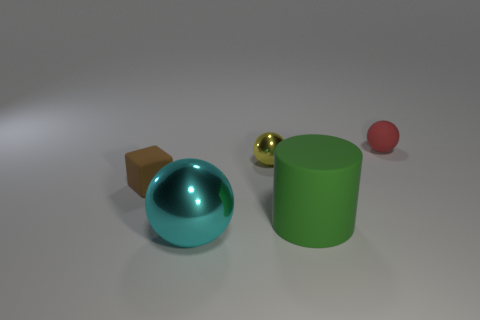Add 1 large cyan balls. How many objects exist? 6 Subtract all spheres. How many objects are left? 2 Subtract 0 green blocks. How many objects are left? 5 Subtract all large balls. Subtract all tiny yellow balls. How many objects are left? 3 Add 3 large rubber things. How many large rubber things are left? 4 Add 4 small red objects. How many small red objects exist? 5 